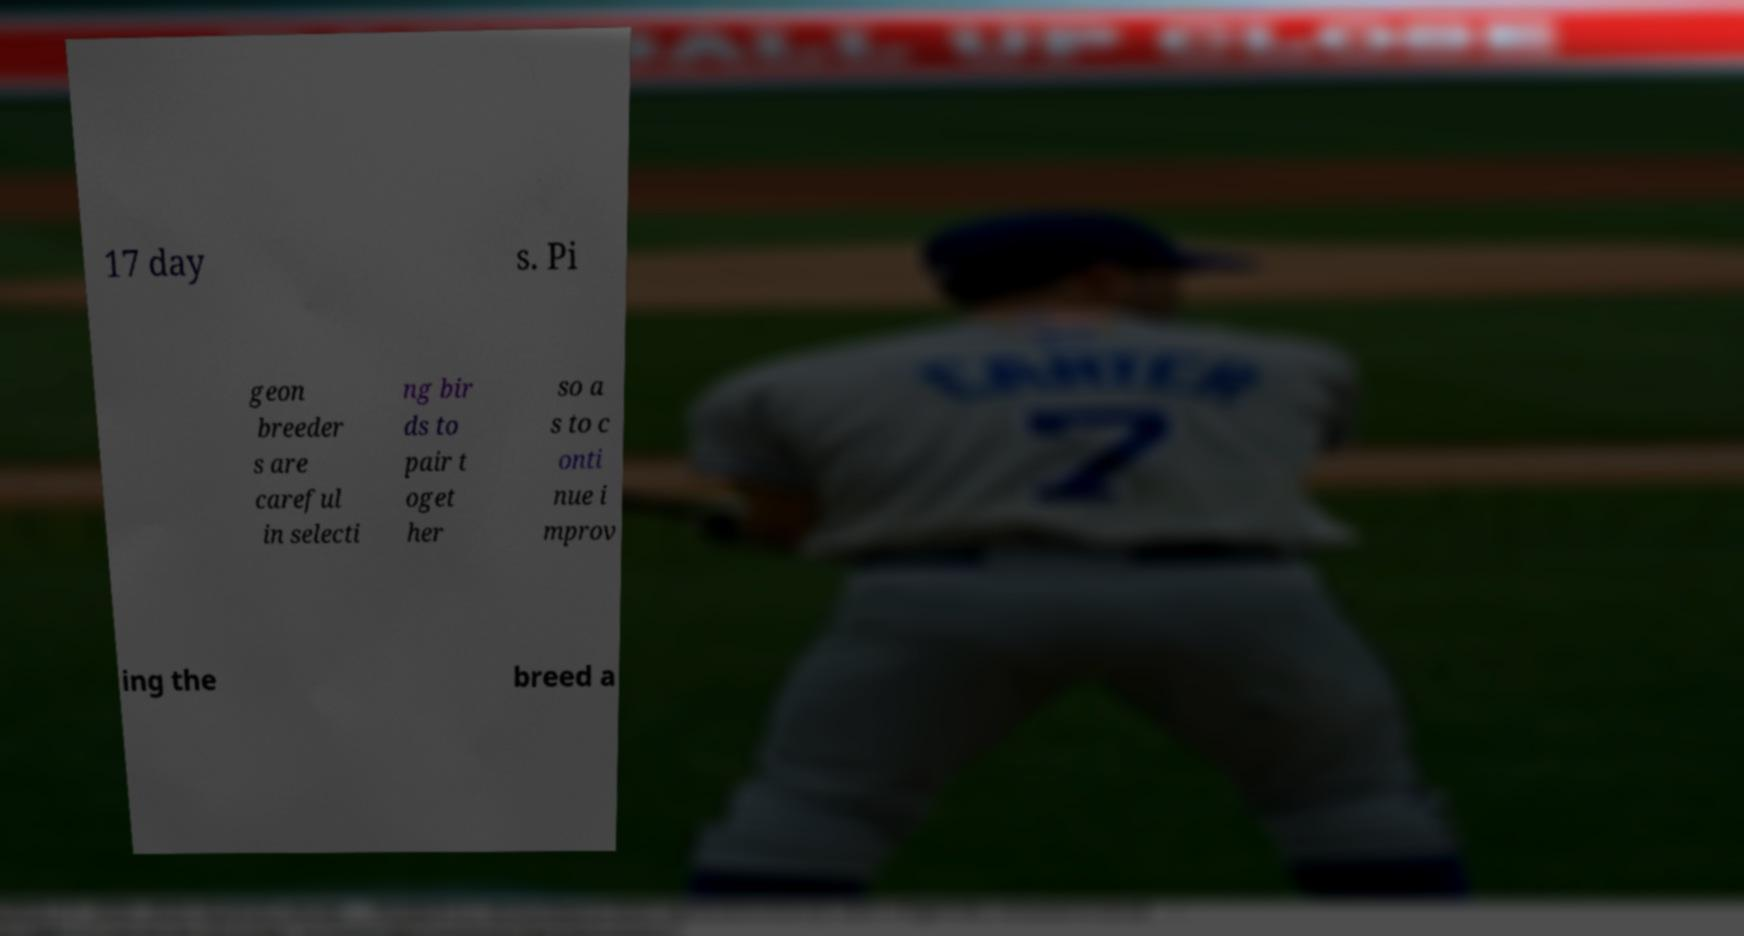There's text embedded in this image that I need extracted. Can you transcribe it verbatim? 17 day s. Pi geon breeder s are careful in selecti ng bir ds to pair t oget her so a s to c onti nue i mprov ing the breed a 